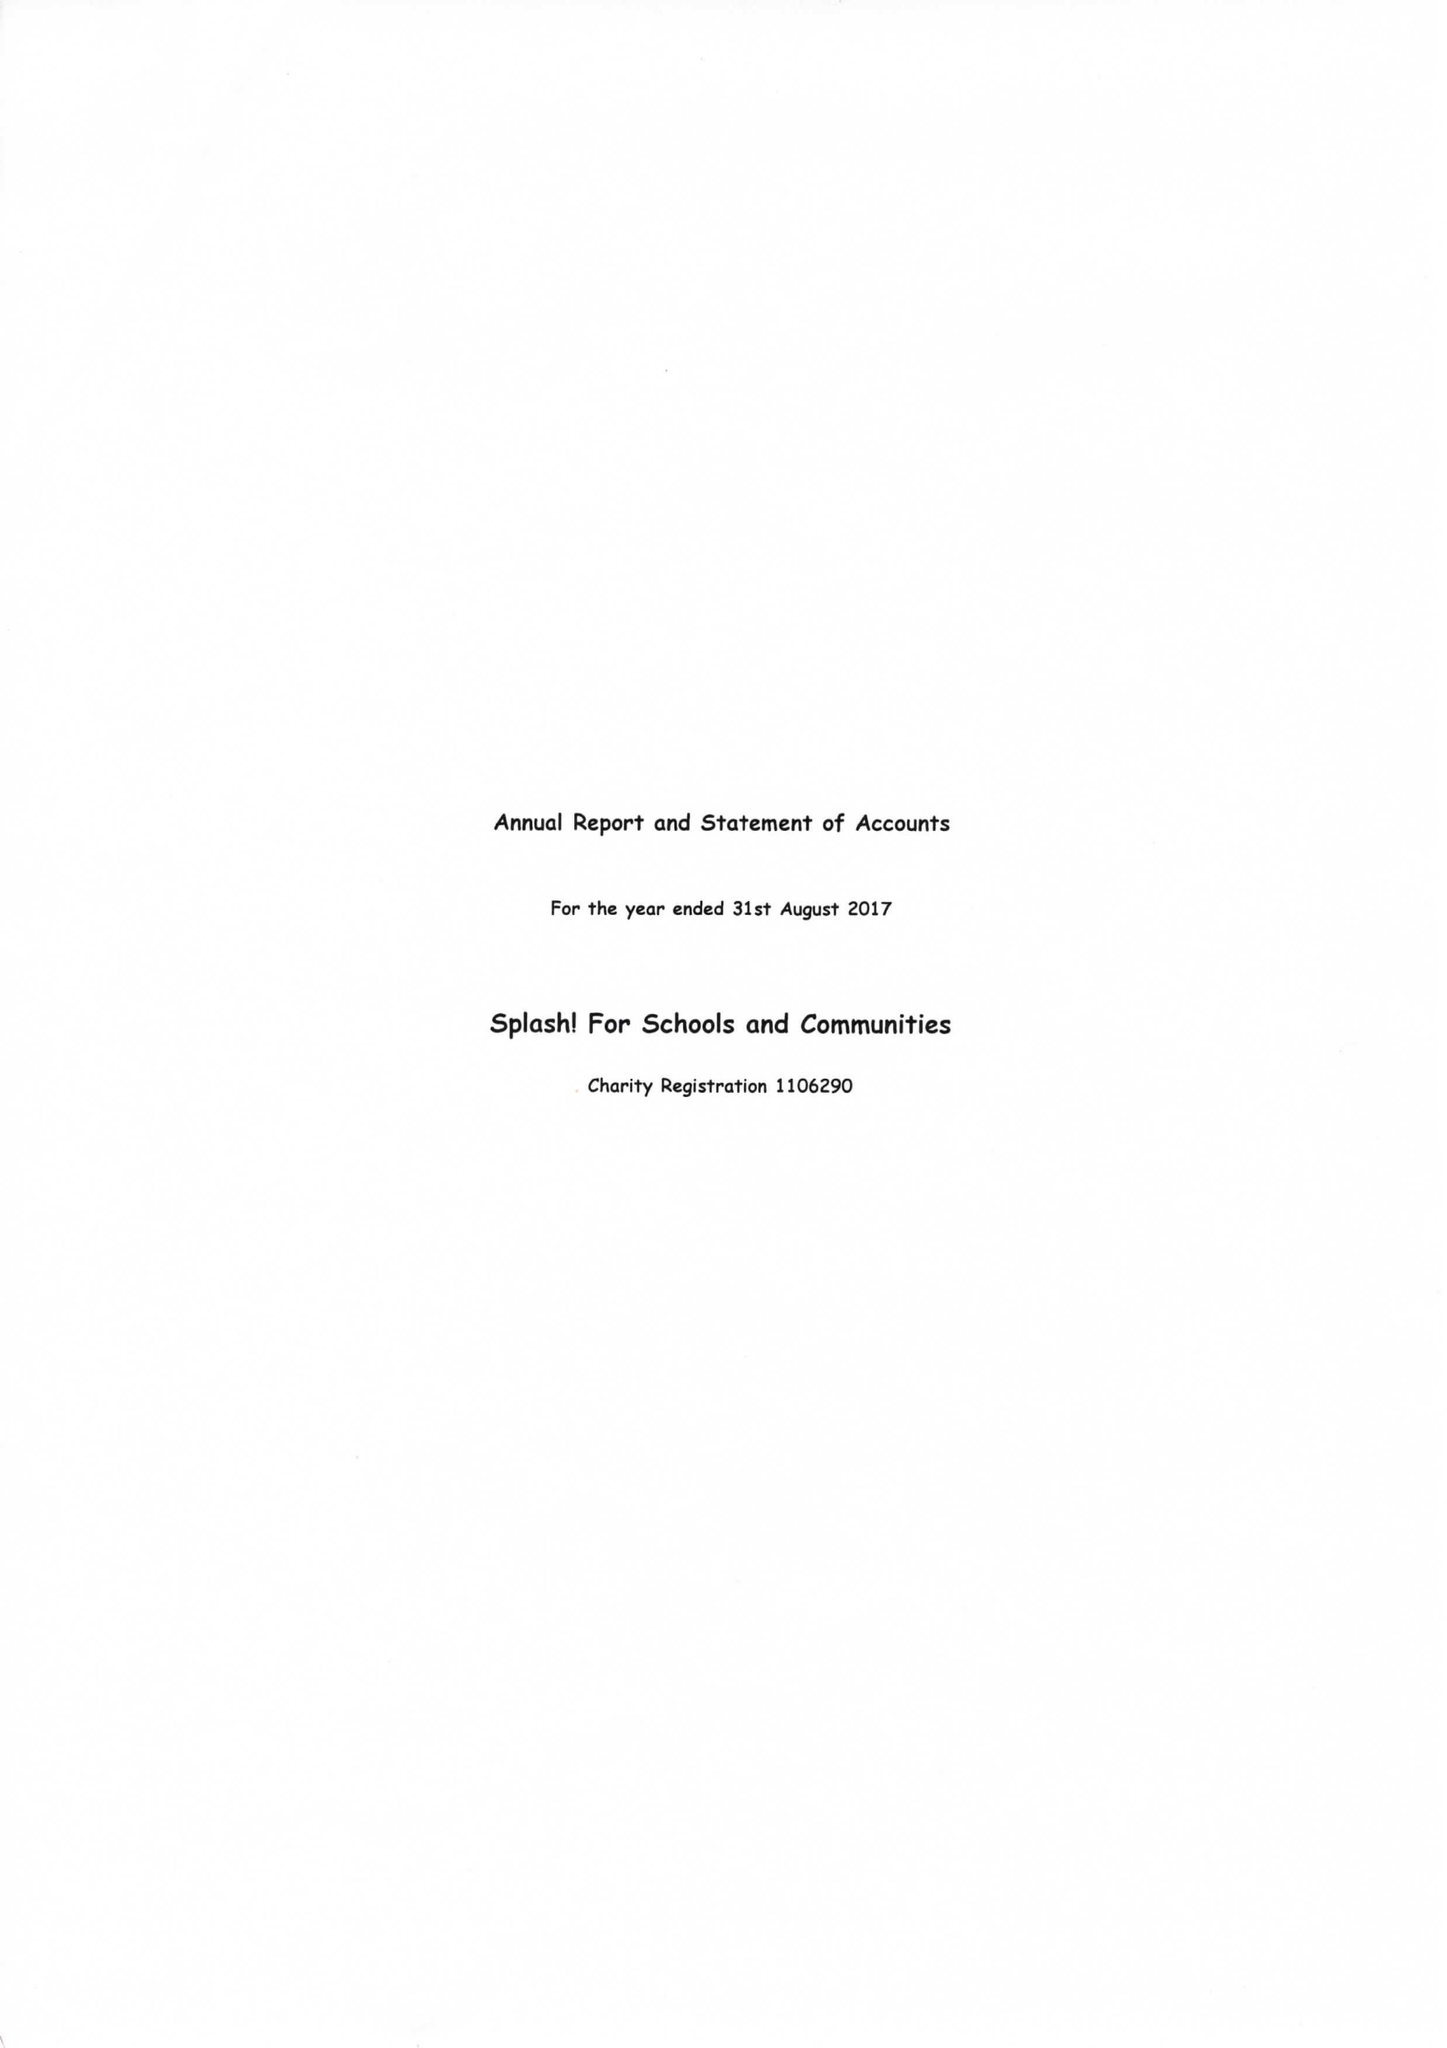What is the value for the income_annually_in_british_pounds?
Answer the question using a single word or phrase. 51517.00 